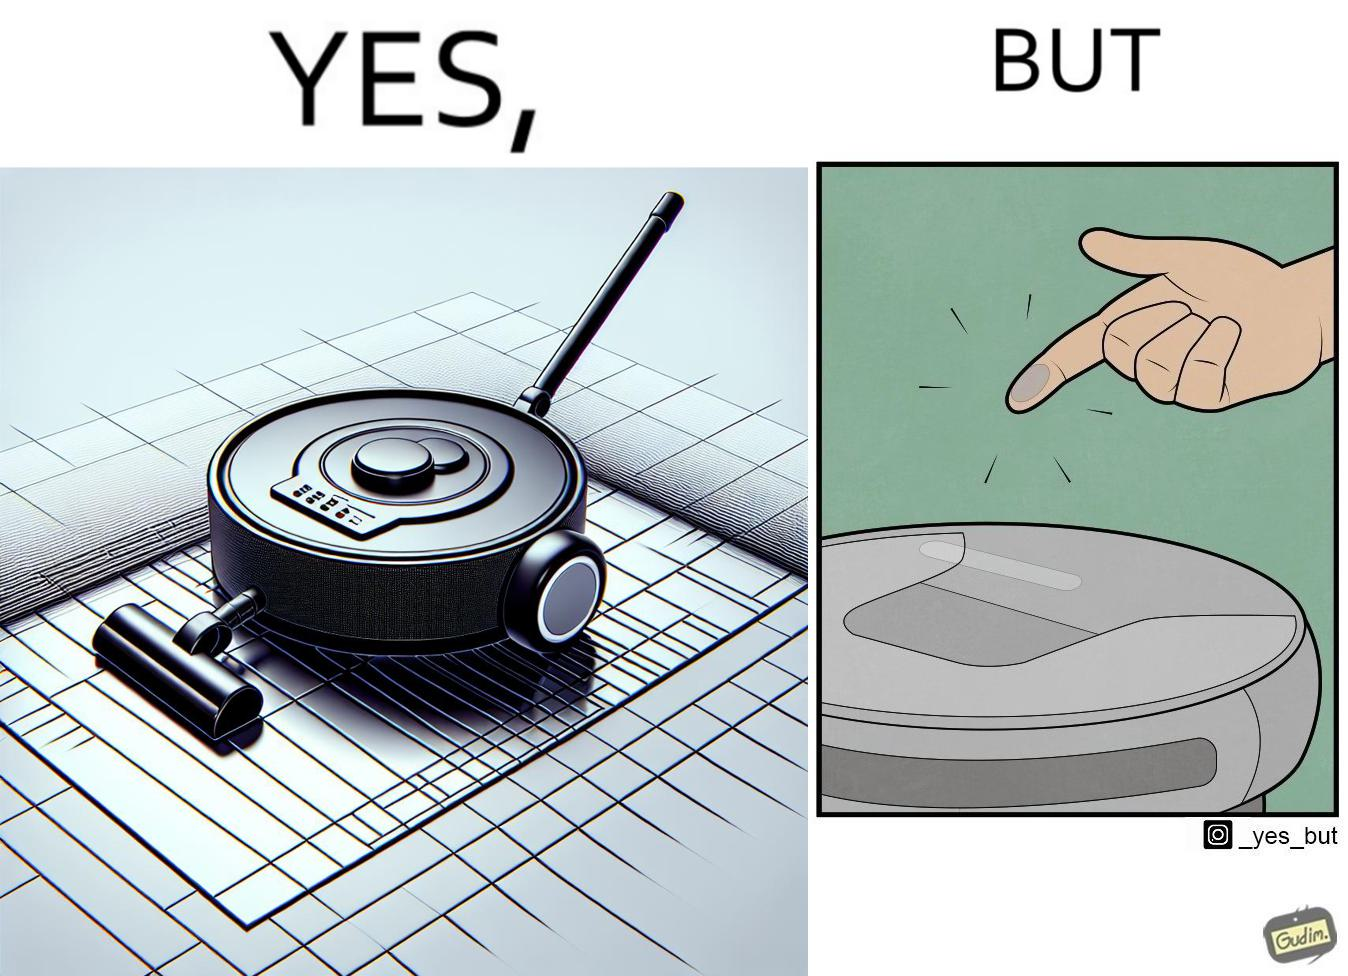Is this a satirical image? Yes, this image is satirical. 